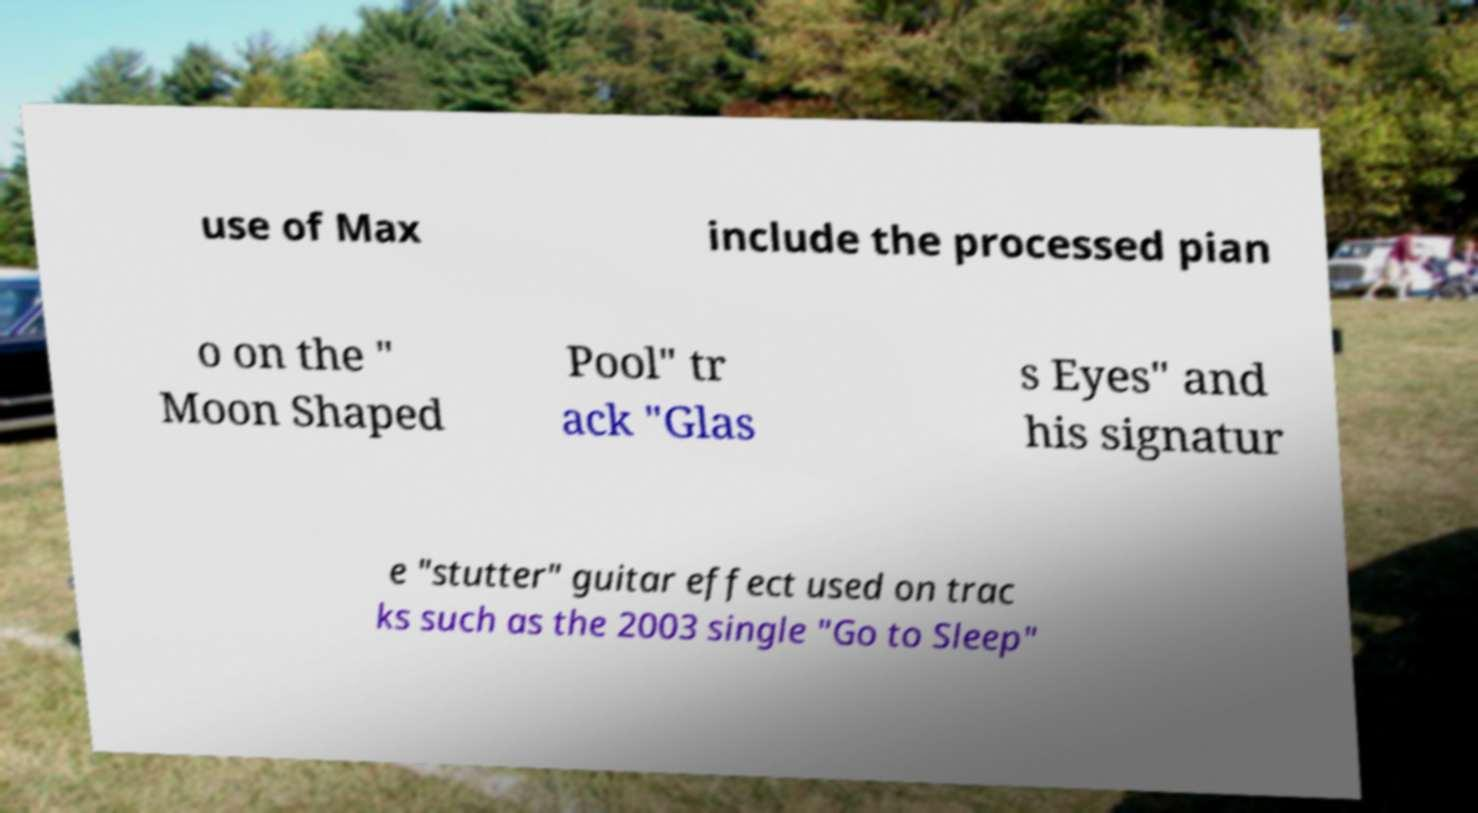Can you accurately transcribe the text from the provided image for me? use of Max include the processed pian o on the " Moon Shaped Pool" tr ack "Glas s Eyes" and his signatur e "stutter" guitar effect used on trac ks such as the 2003 single "Go to Sleep" 